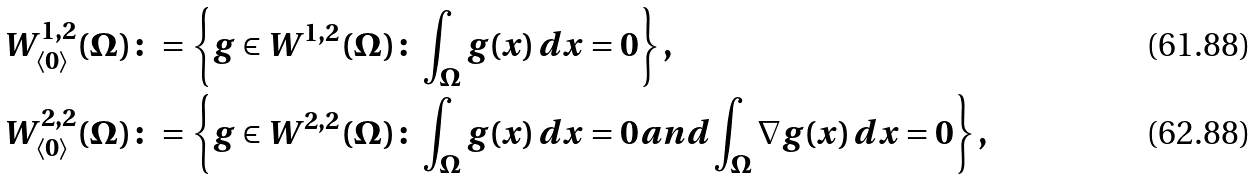<formula> <loc_0><loc_0><loc_500><loc_500>W ^ { 1 , 2 } _ { \langle 0 \rangle } ( \Omega ) & \colon = \left \{ g \in W ^ { 1 , 2 } ( \Omega ) \colon \int _ { \Omega } g ( x ) \, d x = 0 \right \} , \\ W ^ { 2 , 2 } _ { \langle 0 \rangle } ( \Omega ) & \colon = \left \{ g \in W ^ { 2 , 2 } ( \Omega ) \colon \int _ { \Omega } g ( x ) \, d x = 0 a n d \int _ { \Omega } \nabla g ( x ) \, d x = 0 \right \} ,</formula> 